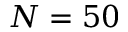Convert formula to latex. <formula><loc_0><loc_0><loc_500><loc_500>N = 5 0</formula> 